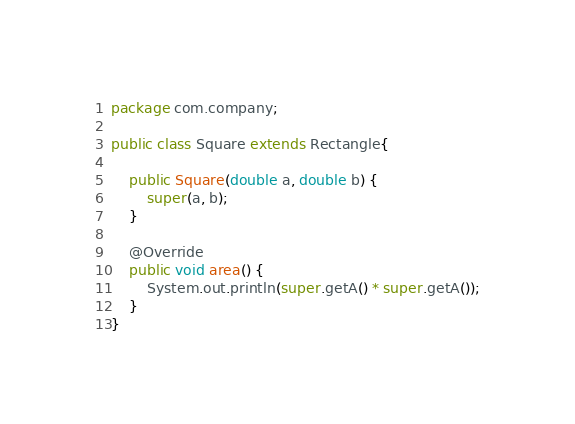<code> <loc_0><loc_0><loc_500><loc_500><_Java_>package com.company;

public class Square extends Rectangle{

    public Square(double a, double b) {
        super(a, b);
    }

    @Override
    public void area() {
        System.out.println(super.getA() * super.getA());
    }
}
</code> 